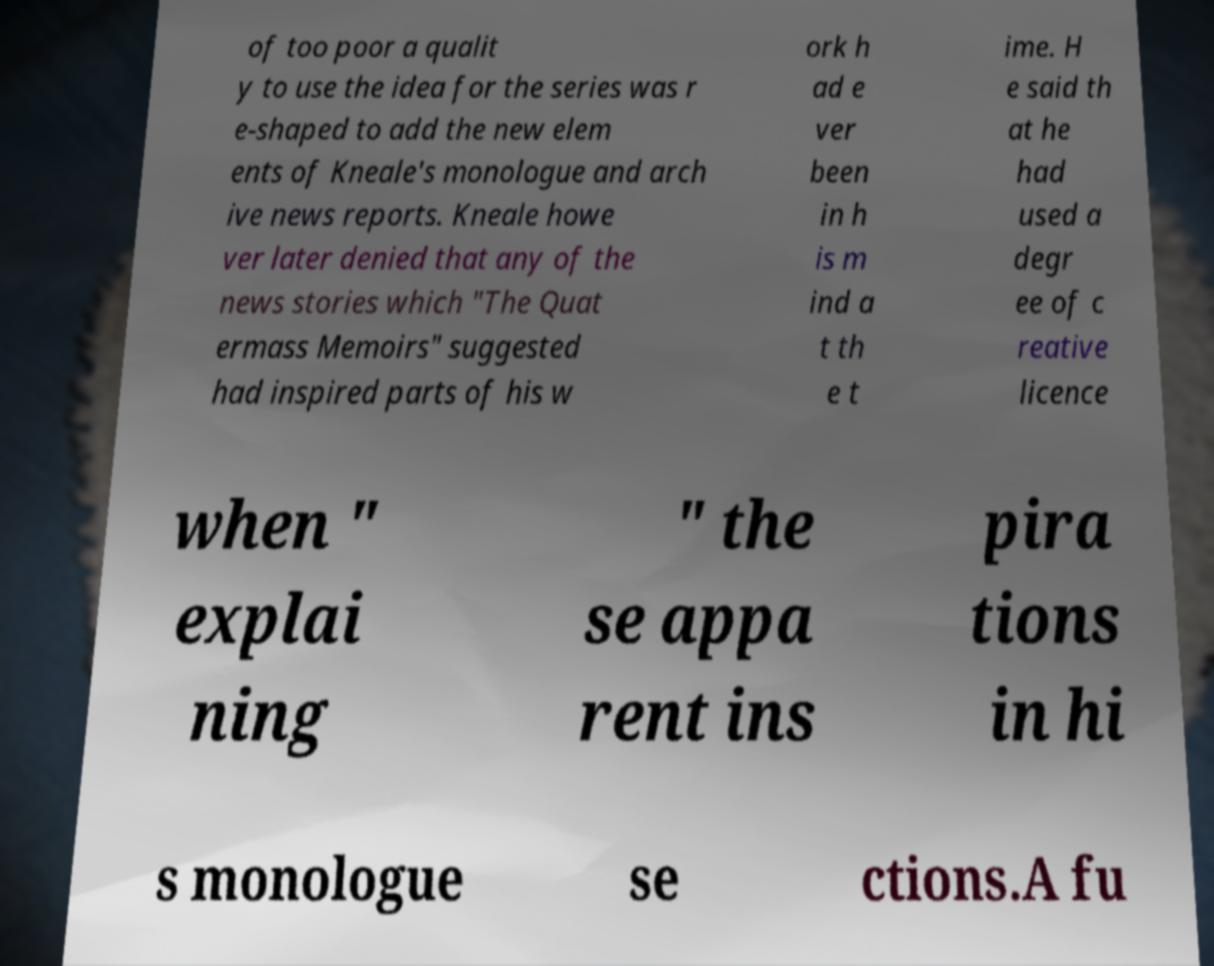Please identify and transcribe the text found in this image. of too poor a qualit y to use the idea for the series was r e-shaped to add the new elem ents of Kneale's monologue and arch ive news reports. Kneale howe ver later denied that any of the news stories which "The Quat ermass Memoirs" suggested had inspired parts of his w ork h ad e ver been in h is m ind a t th e t ime. H e said th at he had used a degr ee of c reative licence when " explai ning " the se appa rent ins pira tions in hi s monologue se ctions.A fu 